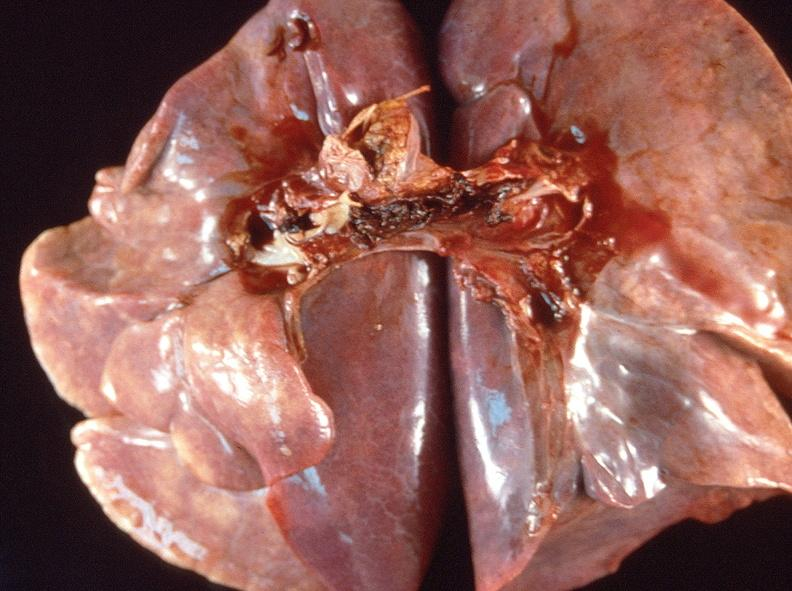what does this image show?
Answer the question using a single word or phrase. Pulmonary thromboemboli 